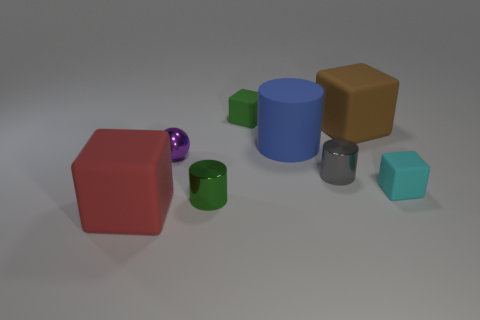Add 1 blue matte cylinders. How many objects exist? 9 Subtract all spheres. How many objects are left? 7 Subtract 0 blue blocks. How many objects are left? 8 Subtract all metal cylinders. Subtract all balls. How many objects are left? 5 Add 2 large things. How many large things are left? 5 Add 6 tiny green matte cubes. How many tiny green matte cubes exist? 7 